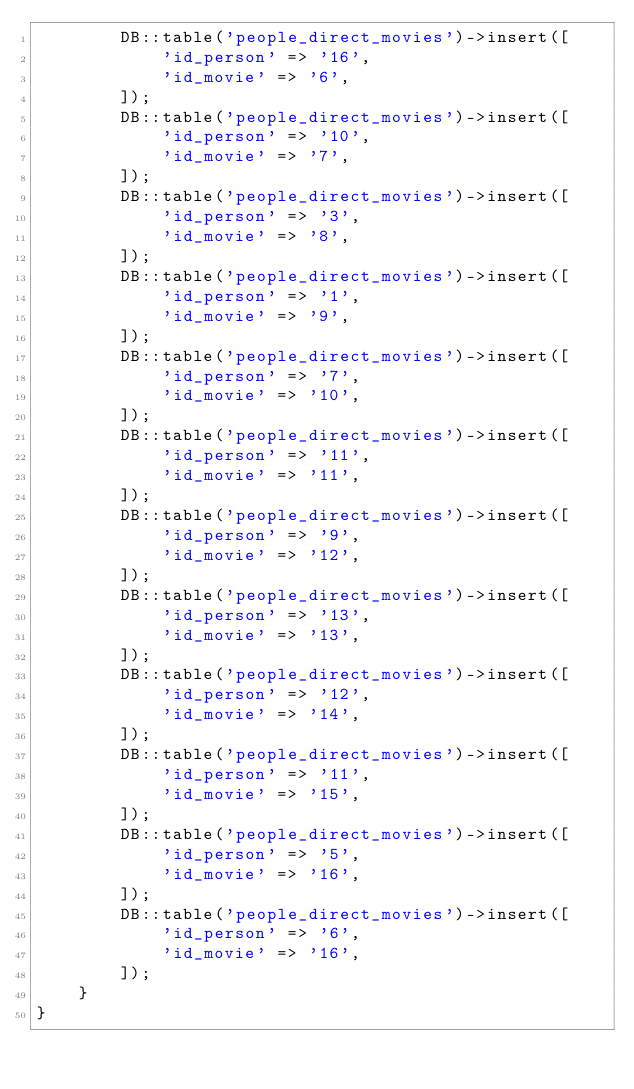<code> <loc_0><loc_0><loc_500><loc_500><_PHP_>        DB::table('people_direct_movies')->insert([
            'id_person' => '16',
            'id_movie' => '6',
        ]);
        DB::table('people_direct_movies')->insert([
            'id_person' => '10',
            'id_movie' => '7',
        ]);
        DB::table('people_direct_movies')->insert([
            'id_person' => '3',
            'id_movie' => '8',
        ]);
        DB::table('people_direct_movies')->insert([
            'id_person' => '1',
            'id_movie' => '9',
        ]);
        DB::table('people_direct_movies')->insert([
            'id_person' => '7',
            'id_movie' => '10',
        ]);
        DB::table('people_direct_movies')->insert([
            'id_person' => '11',
            'id_movie' => '11',
        ]);
        DB::table('people_direct_movies')->insert([
            'id_person' => '9',
            'id_movie' => '12',
        ]);
        DB::table('people_direct_movies')->insert([
            'id_person' => '13',
            'id_movie' => '13',
        ]);
        DB::table('people_direct_movies')->insert([
            'id_person' => '12',
            'id_movie' => '14',
        ]);
        DB::table('people_direct_movies')->insert([
            'id_person' => '11',
            'id_movie' => '15',
        ]);
        DB::table('people_direct_movies')->insert([
            'id_person' => '5',
            'id_movie' => '16',
        ]);
        DB::table('people_direct_movies')->insert([
            'id_person' => '6',
            'id_movie' => '16',
        ]);
    }
}
</code> 